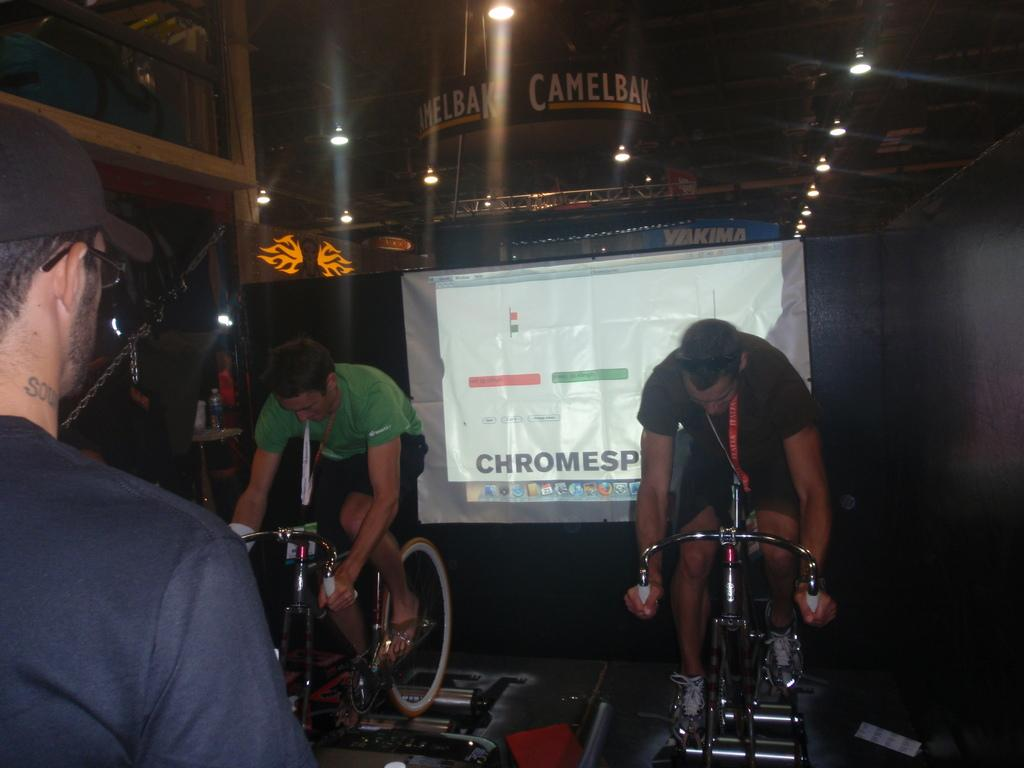How many men are in the image? There are two men in the image. What are the two men doing in the image? The two men are sitting on a bicycle. What can be seen in the background of the image? There is a screen and a light visible in the image. What is the third person in the image doing? There is a man standing in the image. What is connecting the bicycle to the ground in the image? There is a chain in the image. What type of amusement can be seen in the field in the image? There is no field or amusement present in the image. 